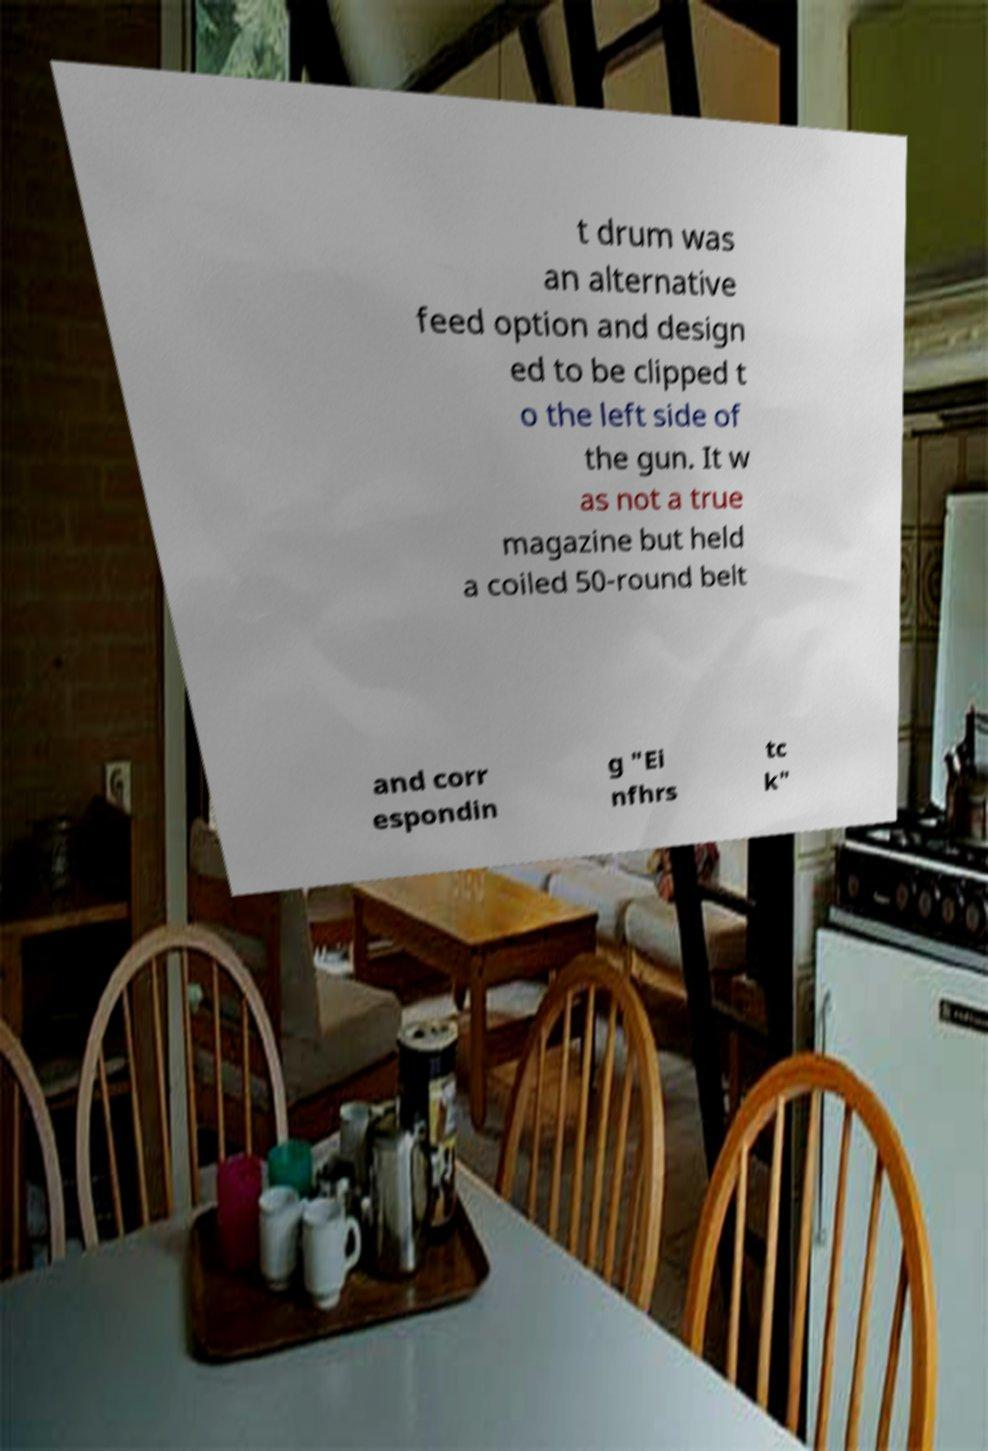Could you extract and type out the text from this image? t drum was an alternative feed option and design ed to be clipped t o the left side of the gun. It w as not a true magazine but held a coiled 50-round belt and corr espondin g "Ei nfhrs tc k" 